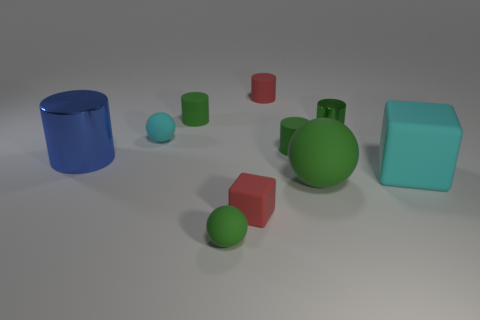What shape is the small matte thing that is the same color as the large cube? sphere 